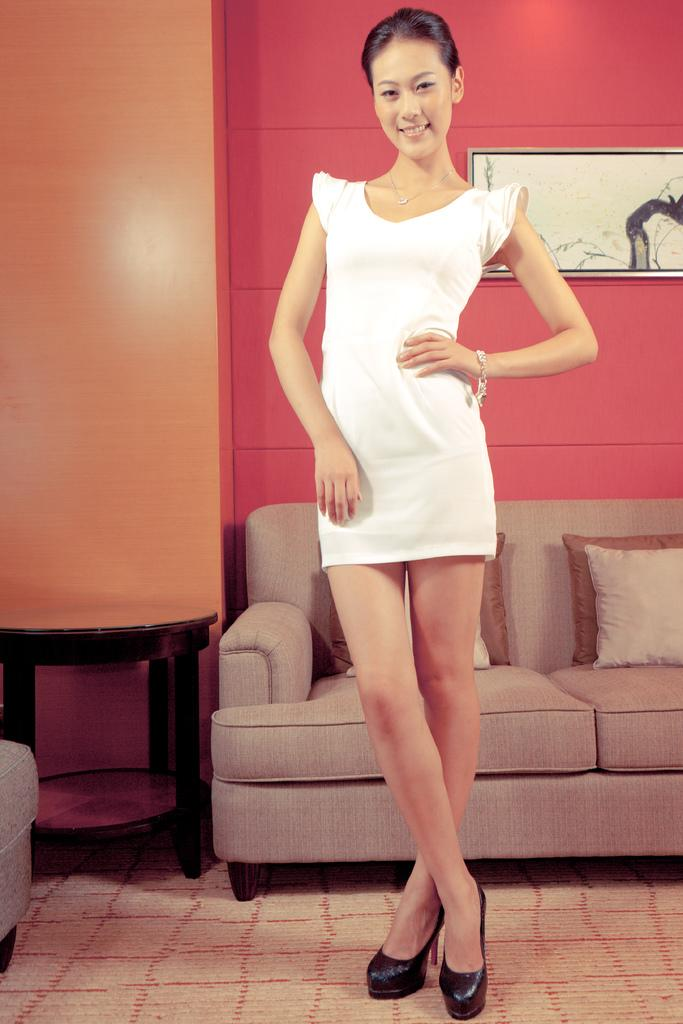Who is present in the image? There is a woman in the image. What is the woman doing in the image? The woman is standing near a sofa. Where does the scene take place? The scene takes place in a room. What type of toys can be seen on the sofa in the image? There are no toys visible in the image; the woman is standing near a sofa, but no toys are mentioned in the facts provided. 